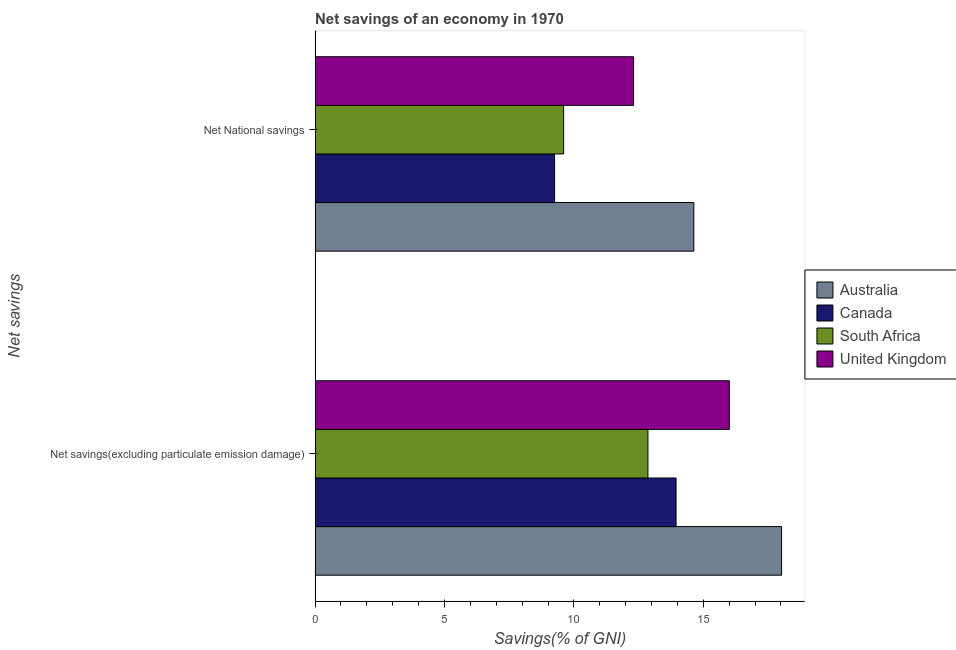Are the number of bars on each tick of the Y-axis equal?
Give a very brief answer. Yes. How many bars are there on the 1st tick from the top?
Offer a very short reply. 4. How many bars are there on the 2nd tick from the bottom?
Give a very brief answer. 4. What is the label of the 1st group of bars from the top?
Your response must be concise. Net National savings. What is the net national savings in South Africa?
Offer a very short reply. 9.6. Across all countries, what is the maximum net savings(excluding particulate emission damage)?
Your answer should be compact. 18.03. Across all countries, what is the minimum net savings(excluding particulate emission damage)?
Your answer should be compact. 12.86. In which country was the net national savings maximum?
Offer a very short reply. Australia. In which country was the net national savings minimum?
Make the answer very short. Canada. What is the total net savings(excluding particulate emission damage) in the graph?
Your answer should be very brief. 60.84. What is the difference between the net national savings in South Africa and that in Canada?
Your answer should be very brief. 0.35. What is the difference between the net savings(excluding particulate emission damage) in United Kingdom and the net national savings in South Africa?
Your answer should be compact. 6.4. What is the average net national savings per country?
Your answer should be compact. 11.45. What is the difference between the net savings(excluding particulate emission damage) and net national savings in Australia?
Offer a very short reply. 3.39. What is the ratio of the net savings(excluding particulate emission damage) in Canada to that in United Kingdom?
Offer a terse response. 0.87. In how many countries, is the net savings(excluding particulate emission damage) greater than the average net savings(excluding particulate emission damage) taken over all countries?
Your response must be concise. 2. What does the 3rd bar from the top in Net savings(excluding particulate emission damage) represents?
Your answer should be very brief. Canada. How many bars are there?
Your answer should be compact. 8. Are all the bars in the graph horizontal?
Offer a terse response. Yes. What is the difference between two consecutive major ticks on the X-axis?
Make the answer very short. 5. Does the graph contain grids?
Provide a short and direct response. No. Where does the legend appear in the graph?
Offer a terse response. Center right. How are the legend labels stacked?
Offer a terse response. Vertical. What is the title of the graph?
Provide a succinct answer. Net savings of an economy in 1970. Does "Sint Maarten (Dutch part)" appear as one of the legend labels in the graph?
Your answer should be very brief. No. What is the label or title of the X-axis?
Your response must be concise. Savings(% of GNI). What is the label or title of the Y-axis?
Provide a short and direct response. Net savings. What is the Savings(% of GNI) of Australia in Net savings(excluding particulate emission damage)?
Provide a short and direct response. 18.03. What is the Savings(% of GNI) of Canada in Net savings(excluding particulate emission damage)?
Provide a short and direct response. 13.95. What is the Savings(% of GNI) of South Africa in Net savings(excluding particulate emission damage)?
Ensure brevity in your answer.  12.86. What is the Savings(% of GNI) of United Kingdom in Net savings(excluding particulate emission damage)?
Give a very brief answer. 16.01. What is the Savings(% of GNI) in Australia in Net National savings?
Offer a terse response. 14.63. What is the Savings(% of GNI) in Canada in Net National savings?
Offer a very short reply. 9.25. What is the Savings(% of GNI) of South Africa in Net National savings?
Give a very brief answer. 9.6. What is the Savings(% of GNI) in United Kingdom in Net National savings?
Provide a short and direct response. 12.31. Across all Net savings, what is the maximum Savings(% of GNI) of Australia?
Keep it short and to the point. 18.03. Across all Net savings, what is the maximum Savings(% of GNI) in Canada?
Give a very brief answer. 13.95. Across all Net savings, what is the maximum Savings(% of GNI) in South Africa?
Your response must be concise. 12.86. Across all Net savings, what is the maximum Savings(% of GNI) of United Kingdom?
Your response must be concise. 16.01. Across all Net savings, what is the minimum Savings(% of GNI) of Australia?
Provide a short and direct response. 14.63. Across all Net savings, what is the minimum Savings(% of GNI) in Canada?
Offer a very short reply. 9.25. Across all Net savings, what is the minimum Savings(% of GNI) in South Africa?
Offer a terse response. 9.6. Across all Net savings, what is the minimum Savings(% of GNI) in United Kingdom?
Ensure brevity in your answer.  12.31. What is the total Savings(% of GNI) of Australia in the graph?
Your answer should be very brief. 32.66. What is the total Savings(% of GNI) in Canada in the graph?
Offer a very short reply. 23.2. What is the total Savings(% of GNI) in South Africa in the graph?
Your answer should be very brief. 22.47. What is the total Savings(% of GNI) of United Kingdom in the graph?
Provide a succinct answer. 28.32. What is the difference between the Savings(% of GNI) in Australia in Net savings(excluding particulate emission damage) and that in Net National savings?
Your response must be concise. 3.39. What is the difference between the Savings(% of GNI) in Canada in Net savings(excluding particulate emission damage) and that in Net National savings?
Give a very brief answer. 4.69. What is the difference between the Savings(% of GNI) in South Africa in Net savings(excluding particulate emission damage) and that in Net National savings?
Make the answer very short. 3.26. What is the difference between the Savings(% of GNI) of United Kingdom in Net savings(excluding particulate emission damage) and that in Net National savings?
Keep it short and to the point. 3.7. What is the difference between the Savings(% of GNI) of Australia in Net savings(excluding particulate emission damage) and the Savings(% of GNI) of Canada in Net National savings?
Your answer should be very brief. 8.77. What is the difference between the Savings(% of GNI) of Australia in Net savings(excluding particulate emission damage) and the Savings(% of GNI) of South Africa in Net National savings?
Your answer should be compact. 8.42. What is the difference between the Savings(% of GNI) in Australia in Net savings(excluding particulate emission damage) and the Savings(% of GNI) in United Kingdom in Net National savings?
Keep it short and to the point. 5.72. What is the difference between the Savings(% of GNI) of Canada in Net savings(excluding particulate emission damage) and the Savings(% of GNI) of South Africa in Net National savings?
Your answer should be very brief. 4.34. What is the difference between the Savings(% of GNI) of Canada in Net savings(excluding particulate emission damage) and the Savings(% of GNI) of United Kingdom in Net National savings?
Your answer should be very brief. 1.64. What is the difference between the Savings(% of GNI) of South Africa in Net savings(excluding particulate emission damage) and the Savings(% of GNI) of United Kingdom in Net National savings?
Your answer should be very brief. 0.55. What is the average Savings(% of GNI) in Australia per Net savings?
Make the answer very short. 16.33. What is the average Savings(% of GNI) of Canada per Net savings?
Your answer should be compact. 11.6. What is the average Savings(% of GNI) of South Africa per Net savings?
Offer a terse response. 11.23. What is the average Savings(% of GNI) in United Kingdom per Net savings?
Provide a short and direct response. 14.16. What is the difference between the Savings(% of GNI) in Australia and Savings(% of GNI) in Canada in Net savings(excluding particulate emission damage)?
Your answer should be compact. 4.08. What is the difference between the Savings(% of GNI) in Australia and Savings(% of GNI) in South Africa in Net savings(excluding particulate emission damage)?
Provide a short and direct response. 5.16. What is the difference between the Savings(% of GNI) in Australia and Savings(% of GNI) in United Kingdom in Net savings(excluding particulate emission damage)?
Ensure brevity in your answer.  2.02. What is the difference between the Savings(% of GNI) in Canada and Savings(% of GNI) in South Africa in Net savings(excluding particulate emission damage)?
Your answer should be very brief. 1.09. What is the difference between the Savings(% of GNI) of Canada and Savings(% of GNI) of United Kingdom in Net savings(excluding particulate emission damage)?
Your answer should be compact. -2.06. What is the difference between the Savings(% of GNI) in South Africa and Savings(% of GNI) in United Kingdom in Net savings(excluding particulate emission damage)?
Ensure brevity in your answer.  -3.15. What is the difference between the Savings(% of GNI) of Australia and Savings(% of GNI) of Canada in Net National savings?
Offer a very short reply. 5.38. What is the difference between the Savings(% of GNI) in Australia and Savings(% of GNI) in South Africa in Net National savings?
Keep it short and to the point. 5.03. What is the difference between the Savings(% of GNI) in Australia and Savings(% of GNI) in United Kingdom in Net National savings?
Offer a terse response. 2.33. What is the difference between the Savings(% of GNI) of Canada and Savings(% of GNI) of South Africa in Net National savings?
Your answer should be very brief. -0.35. What is the difference between the Savings(% of GNI) of Canada and Savings(% of GNI) of United Kingdom in Net National savings?
Ensure brevity in your answer.  -3.05. What is the difference between the Savings(% of GNI) of South Africa and Savings(% of GNI) of United Kingdom in Net National savings?
Give a very brief answer. -2.7. What is the ratio of the Savings(% of GNI) in Australia in Net savings(excluding particulate emission damage) to that in Net National savings?
Your response must be concise. 1.23. What is the ratio of the Savings(% of GNI) of Canada in Net savings(excluding particulate emission damage) to that in Net National savings?
Your response must be concise. 1.51. What is the ratio of the Savings(% of GNI) of South Africa in Net savings(excluding particulate emission damage) to that in Net National savings?
Make the answer very short. 1.34. What is the ratio of the Savings(% of GNI) in United Kingdom in Net savings(excluding particulate emission damage) to that in Net National savings?
Your answer should be very brief. 1.3. What is the difference between the highest and the second highest Savings(% of GNI) in Australia?
Ensure brevity in your answer.  3.39. What is the difference between the highest and the second highest Savings(% of GNI) of Canada?
Your response must be concise. 4.69. What is the difference between the highest and the second highest Savings(% of GNI) in South Africa?
Your answer should be very brief. 3.26. What is the difference between the highest and the second highest Savings(% of GNI) in United Kingdom?
Keep it short and to the point. 3.7. What is the difference between the highest and the lowest Savings(% of GNI) in Australia?
Keep it short and to the point. 3.39. What is the difference between the highest and the lowest Savings(% of GNI) in Canada?
Keep it short and to the point. 4.69. What is the difference between the highest and the lowest Savings(% of GNI) of South Africa?
Provide a succinct answer. 3.26. What is the difference between the highest and the lowest Savings(% of GNI) of United Kingdom?
Offer a terse response. 3.7. 